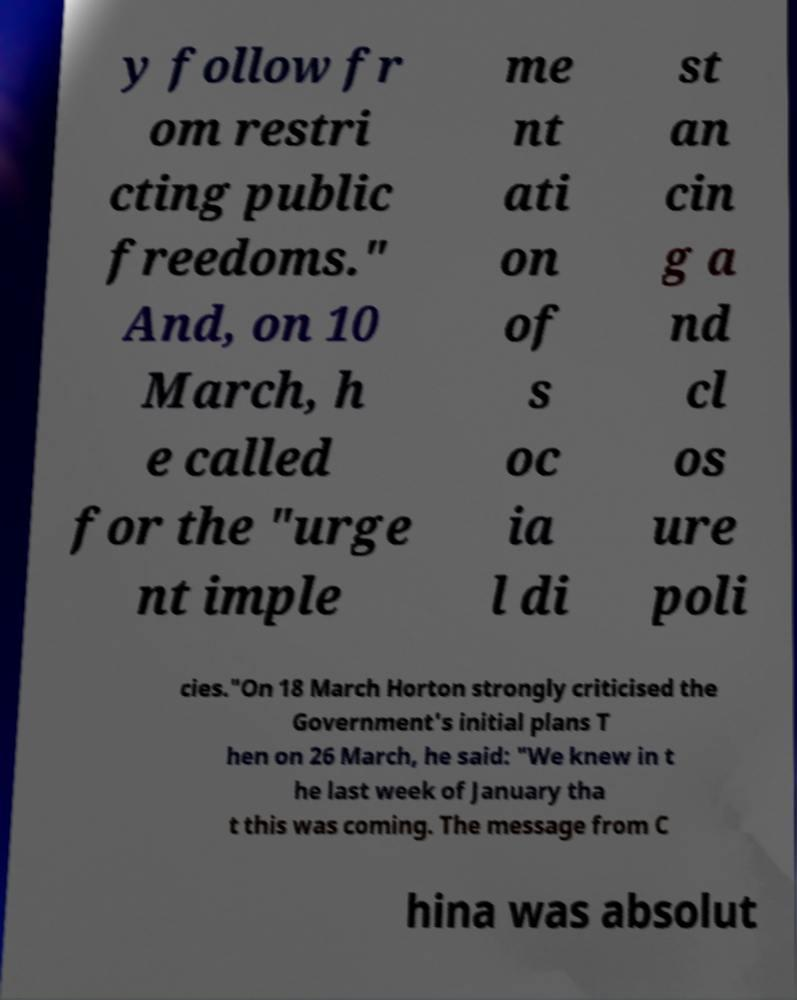For documentation purposes, I need the text within this image transcribed. Could you provide that? y follow fr om restri cting public freedoms." And, on 10 March, h e called for the "urge nt imple me nt ati on of s oc ia l di st an cin g a nd cl os ure poli cies."On 18 March Horton strongly criticised the Government's initial plans T hen on 26 March, he said: "We knew in t he last week of January tha t this was coming. The message from C hina was absolut 